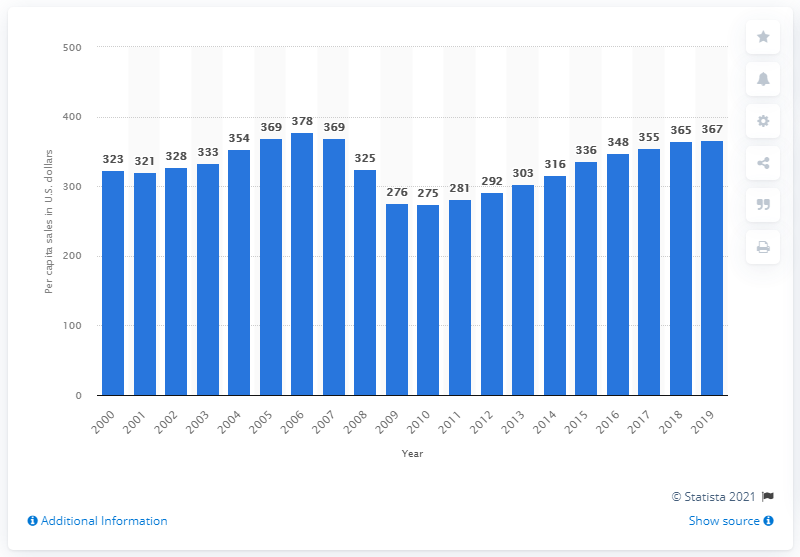List a handful of essential elements in this visual. In 2019, the per capita sales of furniture and home furnishings stores were 367. 